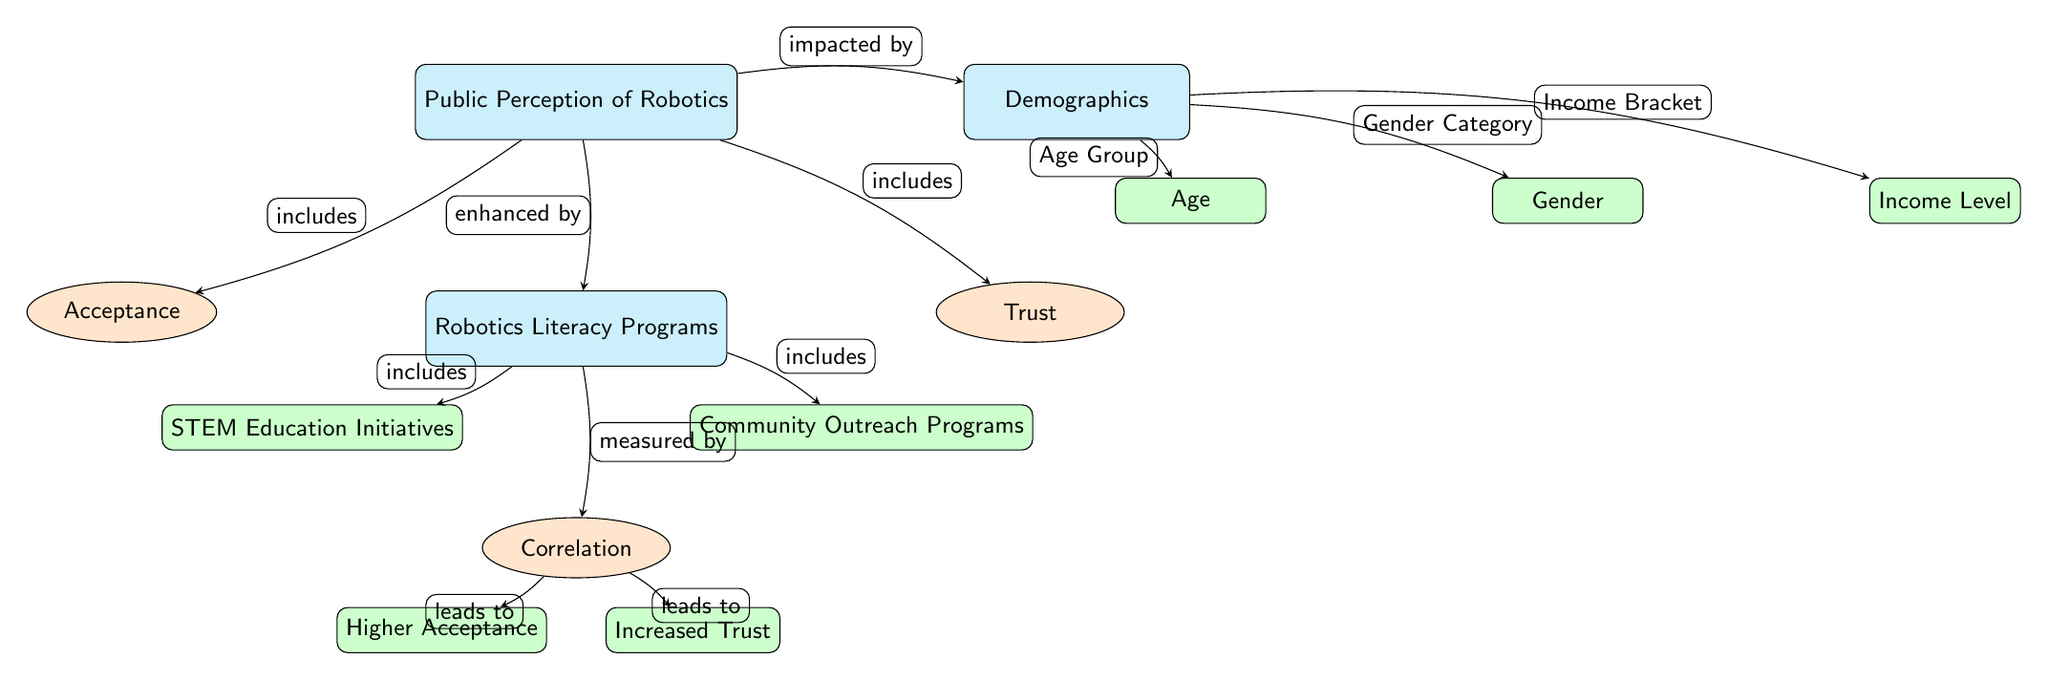What are the two main components of public perception? The diagram identifies two key components of public perception, which are acceptance and trust, as represented by the nodes branching from the main node "Public Perception of Robotics."
Answer: Acceptance and Trust How many demographic factors are shown in the diagram? The diagram lists three demographic factors related to public perception, including age, gender, and income level, as individual subsub nodes under the main demographics node.
Answer: Three What is enhanced by robotics literacy programs? The diagram indicates that public perception of robotics is enhanced by robotics literacy programs, as the connection from the "Robotics Literacy Programs" node to the "Public Perception of Robotics" node shows this relationship.
Answer: Public perception Which demographic factor is directly connected to the "Income Level" node? The diagram shows that the demographics node has direct connections to individual factors, specifically stating "Income Level" as one of the subsub nodes under demographics, making it directly connected.
Answer: Income Level What outcome leads to higher acceptance? According to the diagram, the correlation measured from literacy programs leads to higher acceptance, as indicated by the flow from "Correlation" to "Higher Acceptance."
Answer: Higher Acceptance What types of programs are included under robotics literacy? The diagram includes two types of programs under "Robotics Literacy Programs": STEM Education Initiatives and Community Outreach Programs, both represented as subsub nodes.
Answer: STEM Education Initiatives and Community Outreach Programs What is the relationship between trust and increased literacy programs? The diagram indicates that increased trust is a result of the correlation established by literacy programs, which implies that higher robotics literacy positively influences public trust.
Answer: Increased Trust Which node directly impacts the perception of robotics by demographic factors? The diagram illustrates that demographics directly impact the perception of robotics, specifically mentioned as influencing both acceptance and trust within the relationship to public perception.
Answer: Demographics What leads from "Correlation" to "Increased Trust"? The flow shown in the diagram defines a direct link from "Correlation" to "Increased Trust," suggesting that enhanced literacy programs contribute to greater levels of trust.
Answer: Correlation 